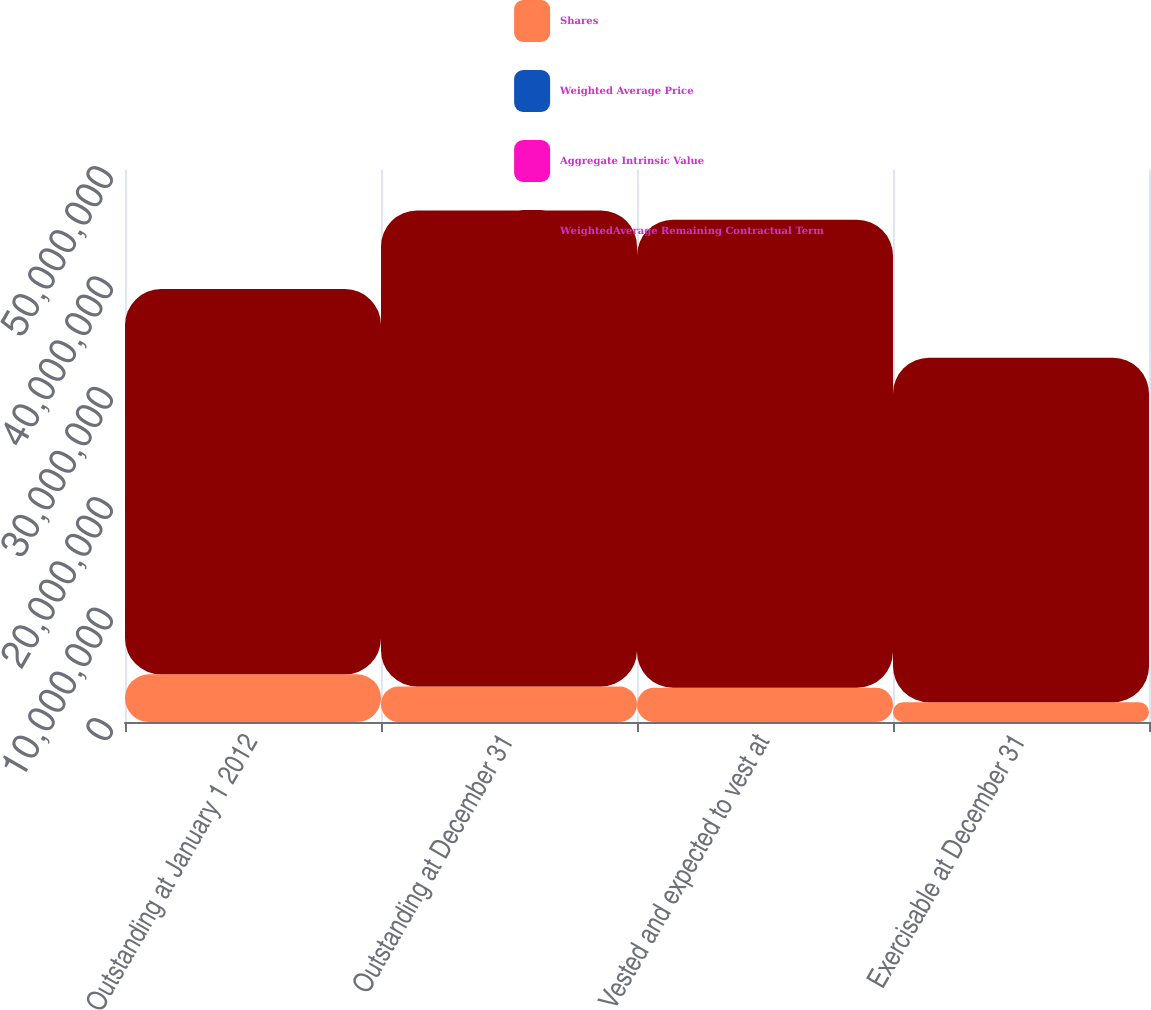<chart> <loc_0><loc_0><loc_500><loc_500><stacked_bar_chart><ecel><fcel>Outstanding at January 1 2012<fcel>Outstanding at December 31<fcel>Vested and expected to vest at<fcel>Exercisable at December 31<nl><fcel>Shares<fcel>4.31404e+06<fcel>3.22374e+06<fcel>3.10093e+06<fcel>1.78076e+06<nl><fcel>Weighted Average Price<fcel>29.61<fcel>33.16<fcel>32.86<fcel>29<nl><fcel>Aggregate Intrinsic Value<fcel>7.01<fcel>6.37<fcel>6.28<fcel>4.82<nl><fcel>WeightedAverage Remaining Contractual Term<fcel>3.48992e+07<fcel>4.31062e+07<fcel>4.23989e+07<fcel>3.12198e+07<nl></chart> 